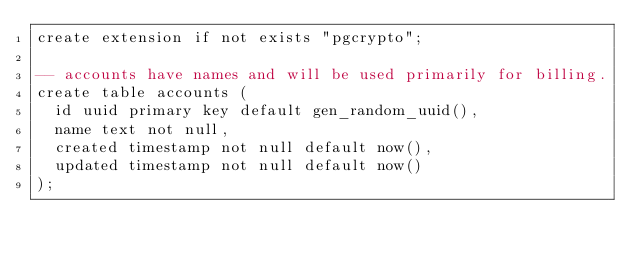<code> <loc_0><loc_0><loc_500><loc_500><_SQL_>create extension if not exists "pgcrypto";

-- accounts have names and will be used primarily for billing.
create table accounts (
  id uuid primary key default gen_random_uuid(),
  name text not null,
  created timestamp not null default now(),
  updated timestamp not null default now()
);
</code> 